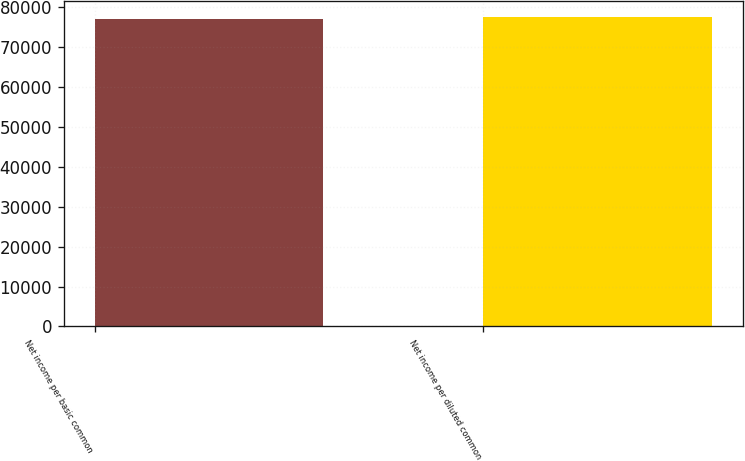<chart> <loc_0><loc_0><loc_500><loc_500><bar_chart><fcel>Net income per basic common<fcel>Net income per diluted common<nl><fcel>76992<fcel>77618<nl></chart> 